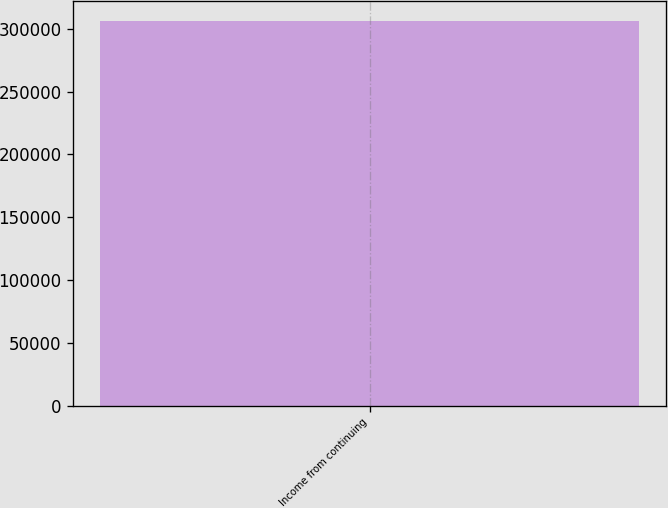Convert chart. <chart><loc_0><loc_0><loc_500><loc_500><bar_chart><fcel>Income from continuing<nl><fcel>306677<nl></chart> 